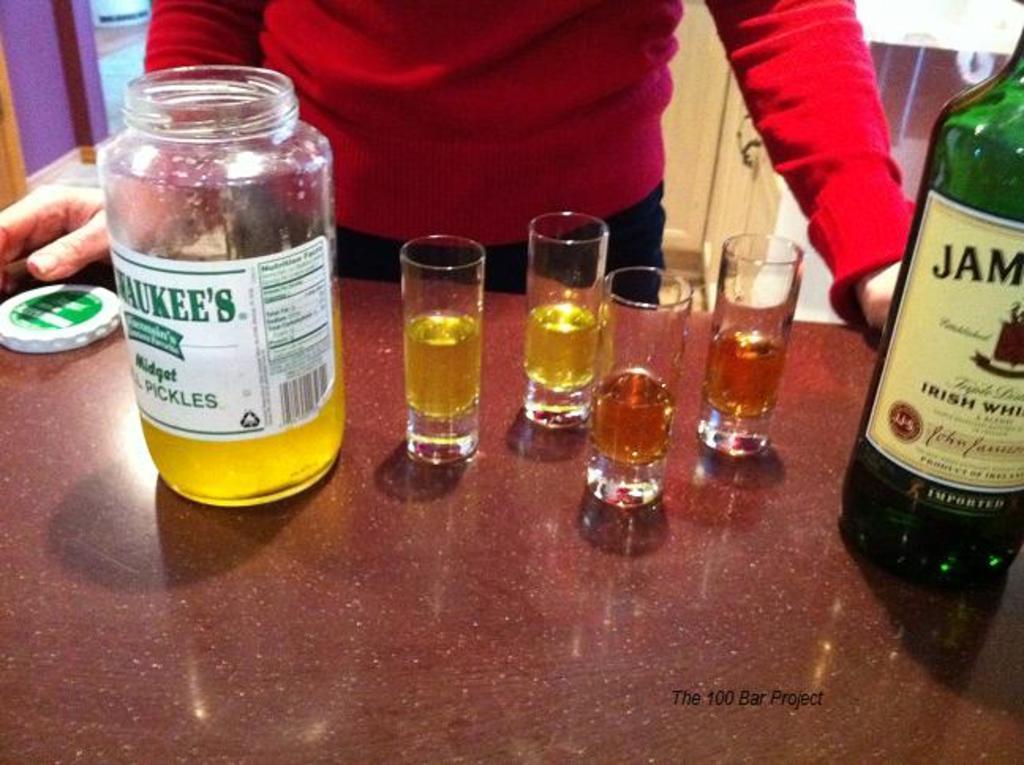Could you give a brief overview of what you see in this image? In this picture we can see a glass jar on the table, and some other glasses with liquid in it and a wine bottle, and in front a person standing. 